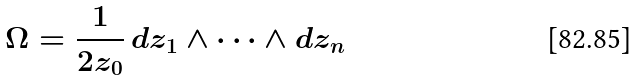<formula> <loc_0><loc_0><loc_500><loc_500>\Omega = \frac { 1 } { 2 z _ { 0 } } \, d z _ { 1 } \wedge \cdots \wedge d z _ { n }</formula> 